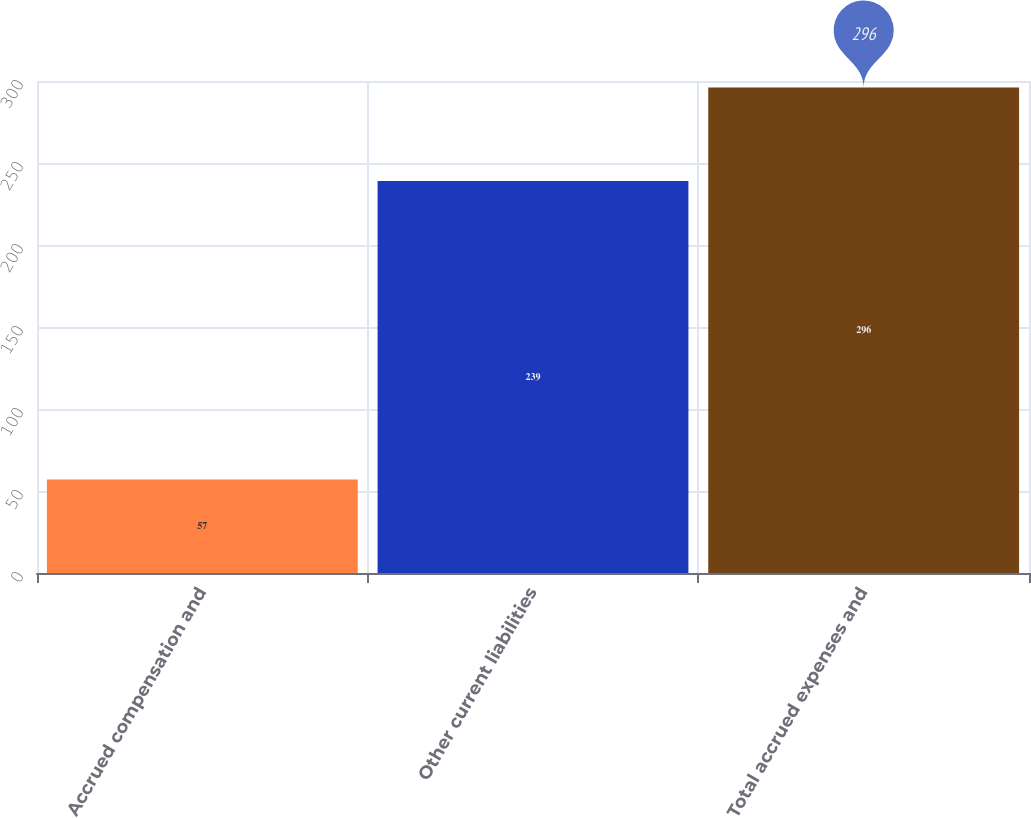Convert chart. <chart><loc_0><loc_0><loc_500><loc_500><bar_chart><fcel>Accrued compensation and<fcel>Other current liabilities<fcel>Total accrued expenses and<nl><fcel>57<fcel>239<fcel>296<nl></chart> 